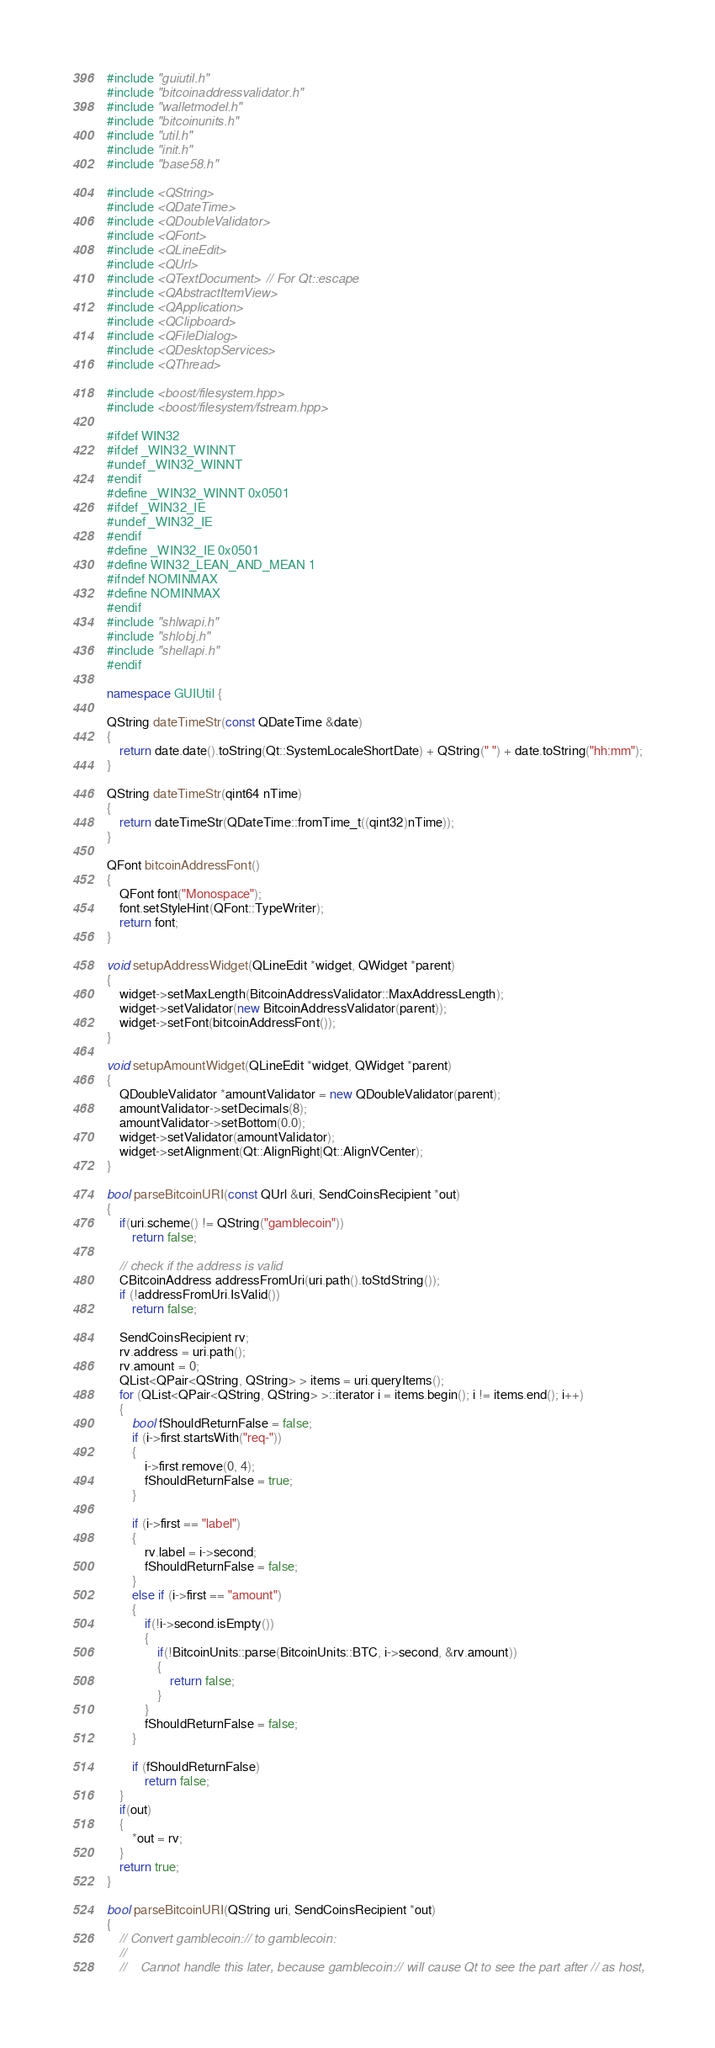Convert code to text. <code><loc_0><loc_0><loc_500><loc_500><_C++_>#include "guiutil.h"
#include "bitcoinaddressvalidator.h"
#include "walletmodel.h"
#include "bitcoinunits.h"
#include "util.h"
#include "init.h"
#include "base58.h"

#include <QString>
#include <QDateTime>
#include <QDoubleValidator>
#include <QFont>
#include <QLineEdit>
#include <QUrl>
#include <QTextDocument> // For Qt::escape
#include <QAbstractItemView>
#include <QApplication>
#include <QClipboard>
#include <QFileDialog>
#include <QDesktopServices>
#include <QThread>

#include <boost/filesystem.hpp>
#include <boost/filesystem/fstream.hpp>

#ifdef WIN32
#ifdef _WIN32_WINNT
#undef _WIN32_WINNT
#endif
#define _WIN32_WINNT 0x0501
#ifdef _WIN32_IE
#undef _WIN32_IE
#endif
#define _WIN32_IE 0x0501
#define WIN32_LEAN_AND_MEAN 1
#ifndef NOMINMAX
#define NOMINMAX
#endif
#include "shlwapi.h"
#include "shlobj.h"
#include "shellapi.h"
#endif

namespace GUIUtil {

QString dateTimeStr(const QDateTime &date)
{
    return date.date().toString(Qt::SystemLocaleShortDate) + QString(" ") + date.toString("hh:mm");
}

QString dateTimeStr(qint64 nTime)
{
    return dateTimeStr(QDateTime::fromTime_t((qint32)nTime));
}

QFont bitcoinAddressFont()
{
    QFont font("Monospace");
    font.setStyleHint(QFont::TypeWriter);
    return font;
}

void setupAddressWidget(QLineEdit *widget, QWidget *parent)
{
    widget->setMaxLength(BitcoinAddressValidator::MaxAddressLength);
    widget->setValidator(new BitcoinAddressValidator(parent));
    widget->setFont(bitcoinAddressFont());
}

void setupAmountWidget(QLineEdit *widget, QWidget *parent)
{
    QDoubleValidator *amountValidator = new QDoubleValidator(parent);
    amountValidator->setDecimals(8);
    amountValidator->setBottom(0.0);
    widget->setValidator(amountValidator);
    widget->setAlignment(Qt::AlignRight|Qt::AlignVCenter);
}

bool parseBitcoinURI(const QUrl &uri, SendCoinsRecipient *out)
{
    if(uri.scheme() != QString("gamblecoin"))
        return false;

    // check if the address is valid
    CBitcoinAddress addressFromUri(uri.path().toStdString());
    if (!addressFromUri.IsValid())
        return false;

    SendCoinsRecipient rv;
    rv.address = uri.path();
    rv.amount = 0;
    QList<QPair<QString, QString> > items = uri.queryItems();
    for (QList<QPair<QString, QString> >::iterator i = items.begin(); i != items.end(); i++)
    {
        bool fShouldReturnFalse = false;
        if (i->first.startsWith("req-"))
        {
            i->first.remove(0, 4);
            fShouldReturnFalse = true;
        }

        if (i->first == "label")
        {
            rv.label = i->second;
            fShouldReturnFalse = false;
        }
        else if (i->first == "amount")
        {
            if(!i->second.isEmpty())
            {
                if(!BitcoinUnits::parse(BitcoinUnits::BTC, i->second, &rv.amount))
                {
                    return false;
                }
            }
            fShouldReturnFalse = false;
        }

        if (fShouldReturnFalse)
            return false;
    }
    if(out)
    {
        *out = rv;
    }
    return true;
}

bool parseBitcoinURI(QString uri, SendCoinsRecipient *out)
{
    // Convert gamblecoin:// to gamblecoin:
    //
    //    Cannot handle this later, because gamblecoin:// will cause Qt to see the part after // as host,</code> 